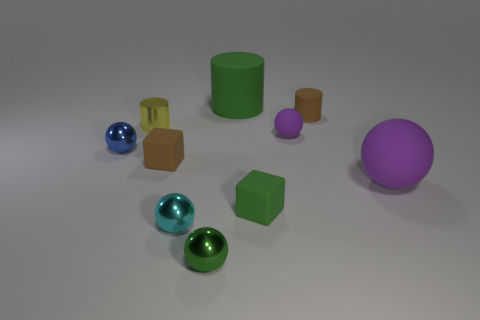There is another sphere that is the same color as the large matte sphere; what size is it?
Offer a very short reply. Small. Are there any tiny green spheres that have the same material as the green cube?
Ensure brevity in your answer.  No. Are the green cylinder and the small brown block made of the same material?
Make the answer very short. Yes. What is the color of the other cylinder that is the same size as the metallic cylinder?
Ensure brevity in your answer.  Brown. What number of other objects are the same shape as the small yellow thing?
Provide a short and direct response. 2. There is a brown cube; is its size the same as the purple matte thing that is behind the tiny blue metallic object?
Ensure brevity in your answer.  Yes. What number of objects are cyan balls or tiny rubber spheres?
Provide a short and direct response. 2. What number of other things are the same size as the green block?
Offer a very short reply. 7. Is the color of the big rubber ball the same as the rubber cube that is in front of the large purple matte object?
Your answer should be compact. No. What number of balls are purple shiny objects or brown things?
Ensure brevity in your answer.  0. 